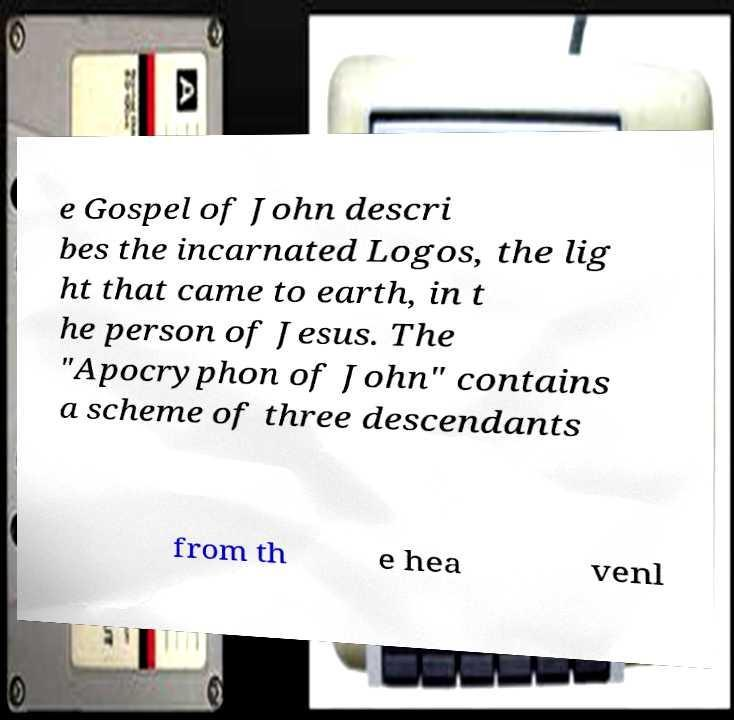There's text embedded in this image that I need extracted. Can you transcribe it verbatim? e Gospel of John descri bes the incarnated Logos, the lig ht that came to earth, in t he person of Jesus. The "Apocryphon of John" contains a scheme of three descendants from th e hea venl 